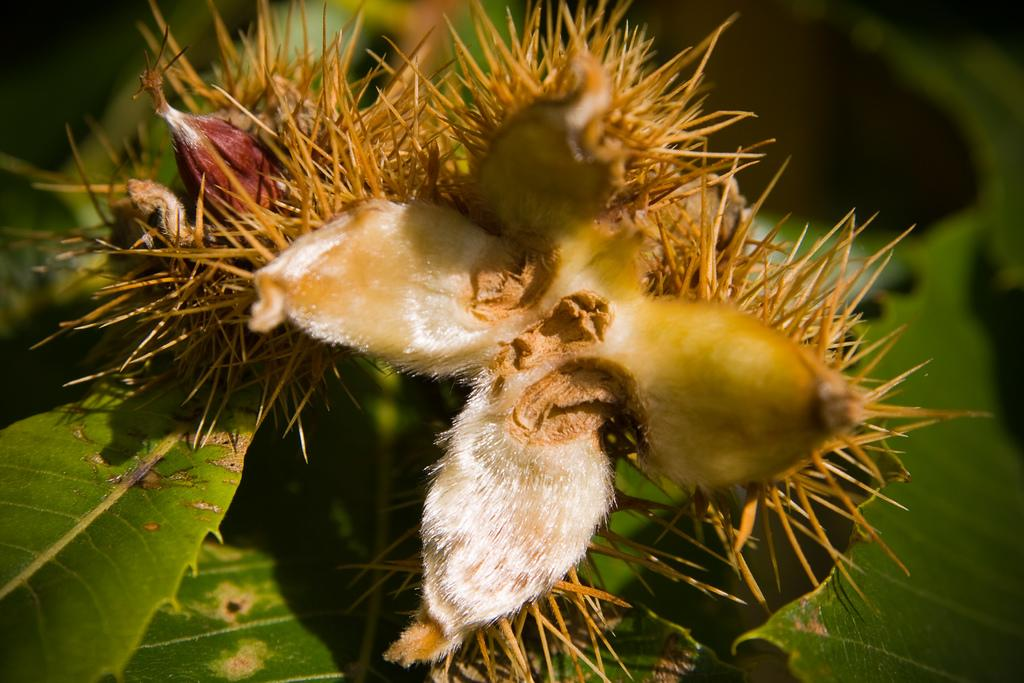What is present in the image? There is a plant in the image. What is unique about the fruits on the plant? The fruits on the plant have thorns. Where are the green leaves located on the plant? The green leaves are on the left side of the plant. Can you describe the background of the image? The background of the image is blurred. How many children are playing with the kettle in the alley in the image? There are no children, kettle, or alley present in the image; it features a plant with fruits and thorns. 